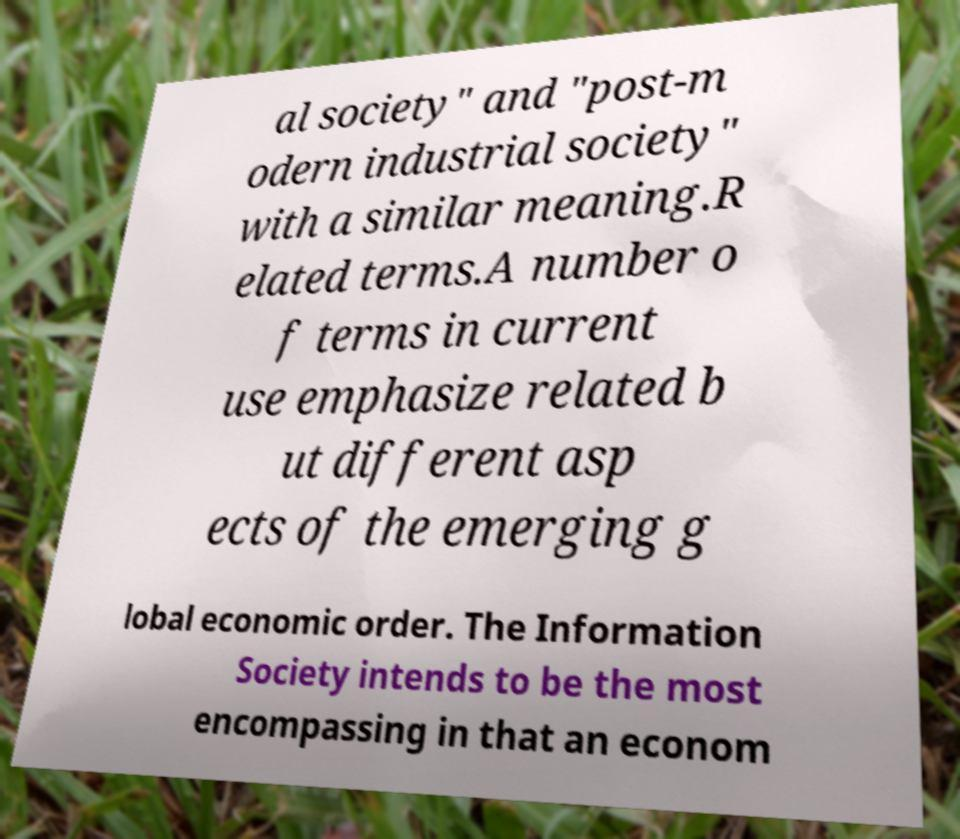What messages or text are displayed in this image? I need them in a readable, typed format. al society" and "post-m odern industrial society" with a similar meaning.R elated terms.A number o f terms in current use emphasize related b ut different asp ects of the emerging g lobal economic order. The Information Society intends to be the most encompassing in that an econom 